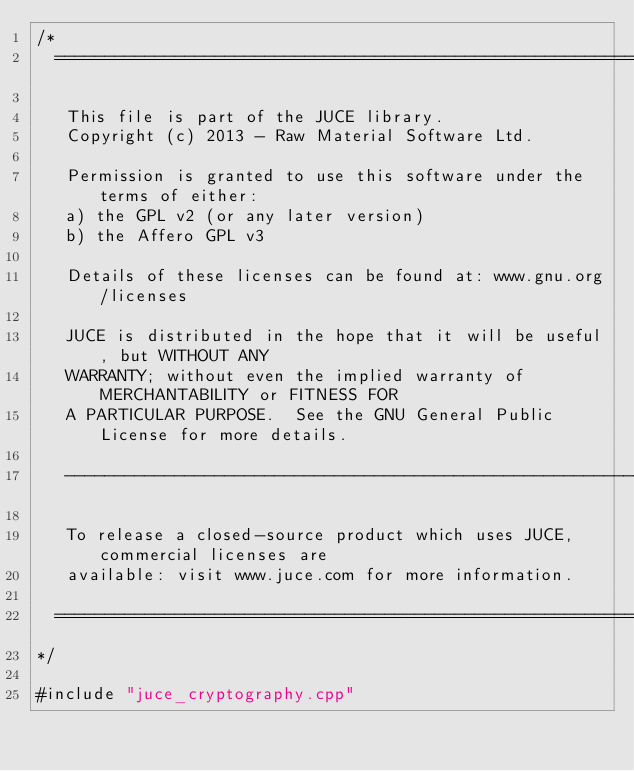<code> <loc_0><loc_0><loc_500><loc_500><_ObjectiveC_>/*
  ==============================================================================

   This file is part of the JUCE library.
   Copyright (c) 2013 - Raw Material Software Ltd.

   Permission is granted to use this software under the terms of either:
   a) the GPL v2 (or any later version)
   b) the Affero GPL v3

   Details of these licenses can be found at: www.gnu.org/licenses

   JUCE is distributed in the hope that it will be useful, but WITHOUT ANY
   WARRANTY; without even the implied warranty of MERCHANTABILITY or FITNESS FOR
   A PARTICULAR PURPOSE.  See the GNU General Public License for more details.

   ------------------------------------------------------------------------------

   To release a closed-source product which uses JUCE, commercial licenses are
   available: visit www.juce.com for more information.

  ==============================================================================
*/

#include "juce_cryptography.cpp"
</code> 